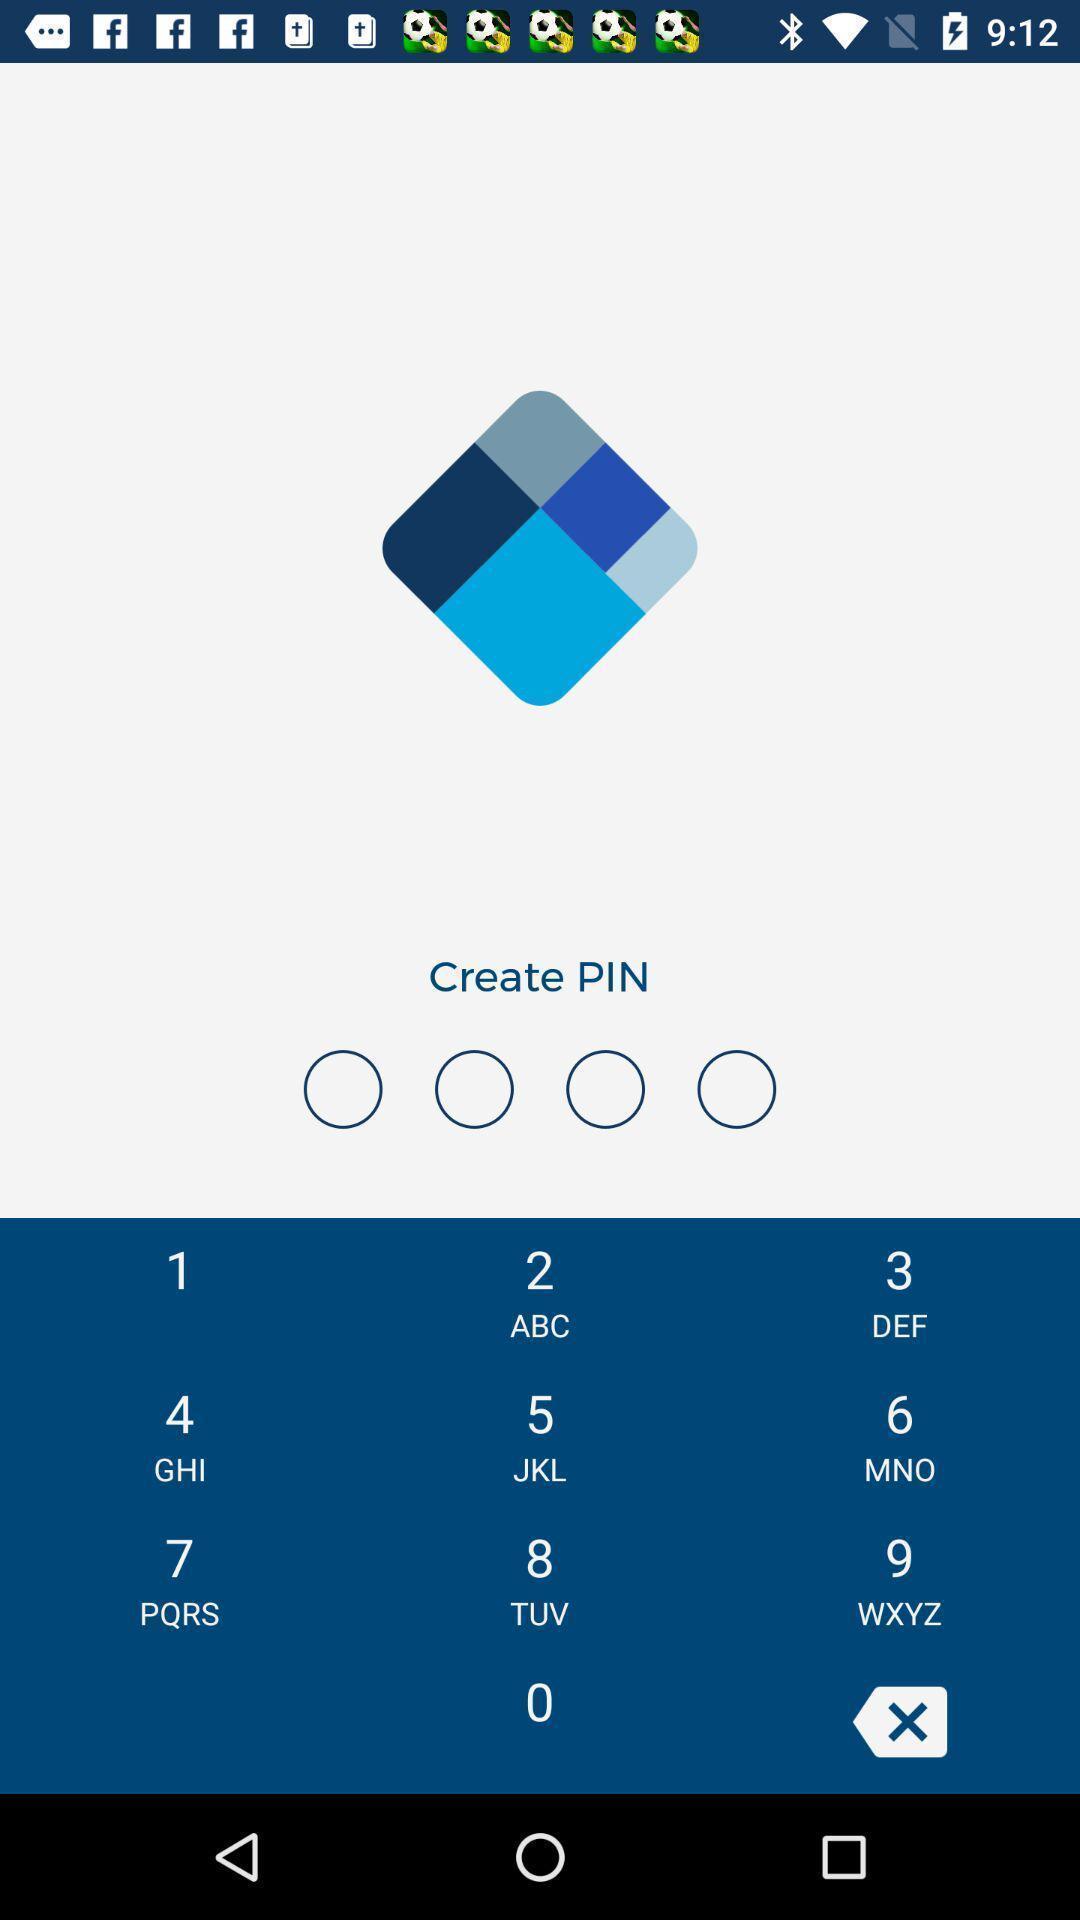Describe the key features of this screenshot. Social app for creating pin. 